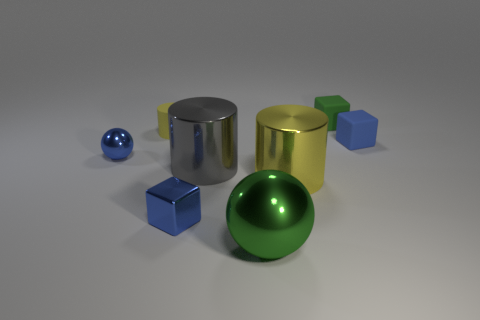Subtract all big cylinders. How many cylinders are left? 1 Add 2 gray shiny cylinders. How many objects exist? 10 Subtract all balls. How many objects are left? 6 Subtract 1 green blocks. How many objects are left? 7 Subtract all yellow metal objects. Subtract all small green things. How many objects are left? 6 Add 1 yellow shiny cylinders. How many yellow shiny cylinders are left? 2 Add 1 large yellow things. How many large yellow things exist? 2 